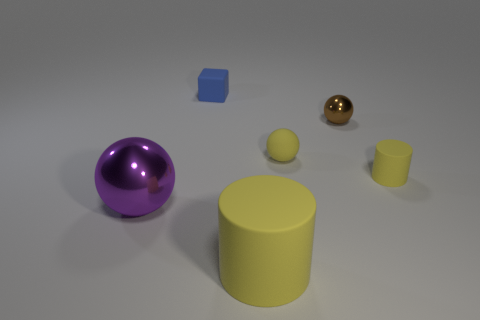What is the material of the yellow thing in front of the large purple sphere?
Offer a very short reply. Rubber. How many yellow cylinders have the same material as the blue cube?
Your answer should be very brief. 2. What shape is the tiny thing that is to the left of the brown metallic ball and on the right side of the blue object?
Keep it short and to the point. Sphere. How many things are either metallic balls right of the tiny rubber ball or matte things that are behind the large rubber thing?
Provide a short and direct response. 4. Is the number of purple metal balls on the left side of the big purple shiny object the same as the number of big purple things on the right side of the tiny brown ball?
Provide a succinct answer. Yes. What is the shape of the yellow object in front of the metal ball on the left side of the tiny brown ball?
Offer a very short reply. Cylinder. Is there a small brown thing that has the same shape as the purple thing?
Provide a succinct answer. Yes. How many small purple metal spheres are there?
Offer a terse response. 0. Does the large thing that is to the right of the purple shiny ball have the same material as the small cylinder?
Your response must be concise. Yes. Are there any purple spheres of the same size as the blue thing?
Provide a short and direct response. No. 